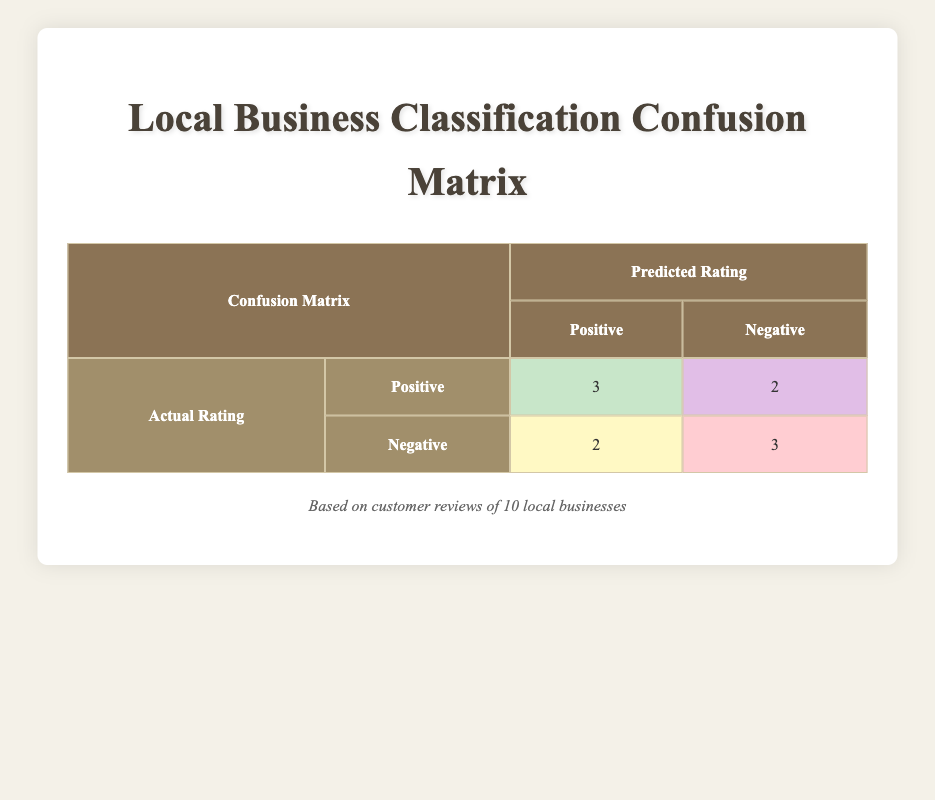What is the total number of local businesses analyzed? The table shows the confusion matrix based on customer reviews of 10 local businesses, meaning that the data pertains to 10 businesses in total.
Answer: 10 How many businesses were classified as positively rated by the model? According to the table, three businesses with an actual positive rating are classified correctly as positive (true positives), plus two businesses with a negative rating that were wrongly classified as positive (false positives). So, the total classified as positive is 3 (true positive) + 2 (false positive) = 5.
Answer: 5 What is the number of true negatives in this analysis? The true negatives are the businesses that were accurately predicted as negative, which is indicated in the table as 3. Thus, there are 3 true negatives.
Answer: 3 Is it true that more businesses received a positive classification than a negative classification? The table indicates that five businesses were classified as positive (3 true positives + 2 false positives) while only 3 were classified as negative (2 false negatives + 3 true negatives). Since 5 is greater than 3, the statement is true.
Answer: Yes How many more false negatives are there than true positives? The table shows there are 2 false negatives and 3 true positives. To determine the difference, we subtract the number of true positives from the false negatives: 2 (false negatives) - 3 (true positives) = -1, indicating there is 1 less true positive than false negatives.
Answer: 1 less What percentage of businesses that were truly rated positive received the correct prediction? There are 3 true positives out of a total of 5 actual positive ratings (3 true positives + 2 false negatives). Calculating the percentage gives (3/5) * 100% = 60%, reflecting that 60% of the businesses that were truly rated positive were correctly identified.
Answer: 60% What is the total number of false positives and false negatives combined? The table shows there are 2 false positives and 2 false negatives. Adding these together gives a total of 2 (false positives) + 2 (false negatives) = 4.
Answer: 4 How would you summarize the overall performance regarding positive predictions? The total true positives were 3 while false positives were 2, showing that while three businesses were correctly identified, two others were wrongly classified as positive. Thus, three out of eight predictions were accurate, which suggests the positive prediction rate is moderate.
Answer: Moderate performance 